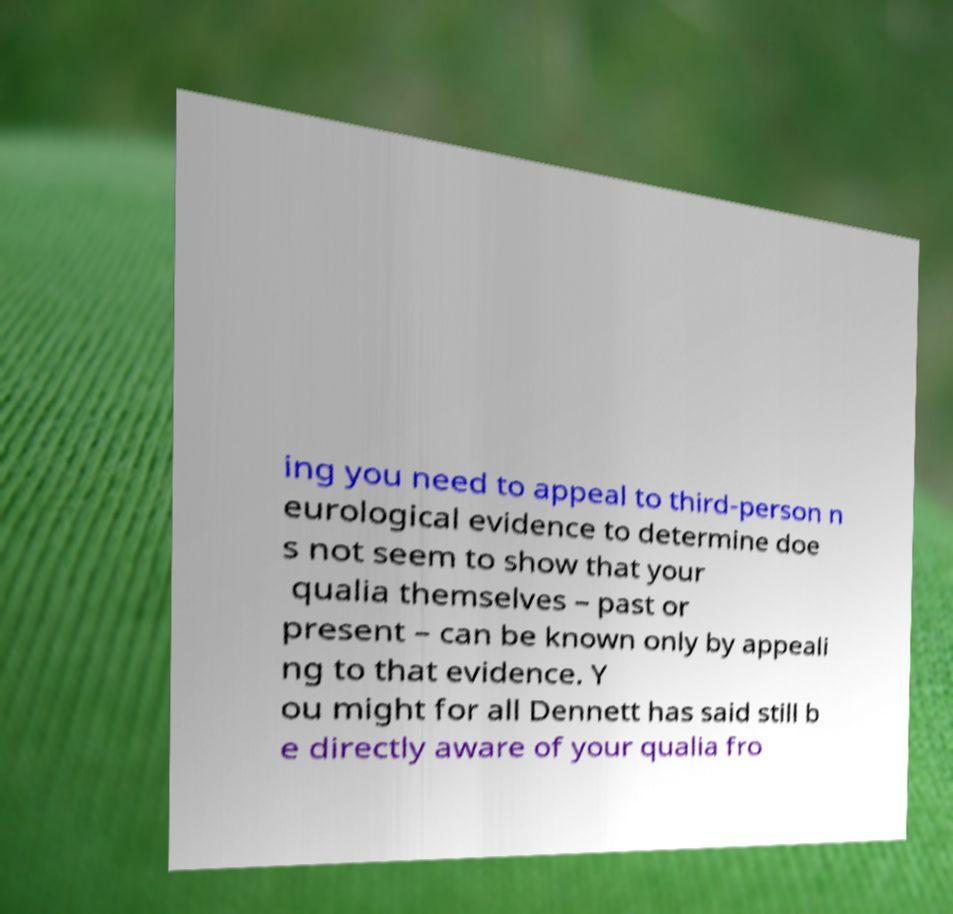Can you accurately transcribe the text from the provided image for me? ing you need to appeal to third-person n eurological evidence to determine doe s not seem to show that your qualia themselves – past or present – can be known only by appeali ng to that evidence. Y ou might for all Dennett has said still b e directly aware of your qualia fro 